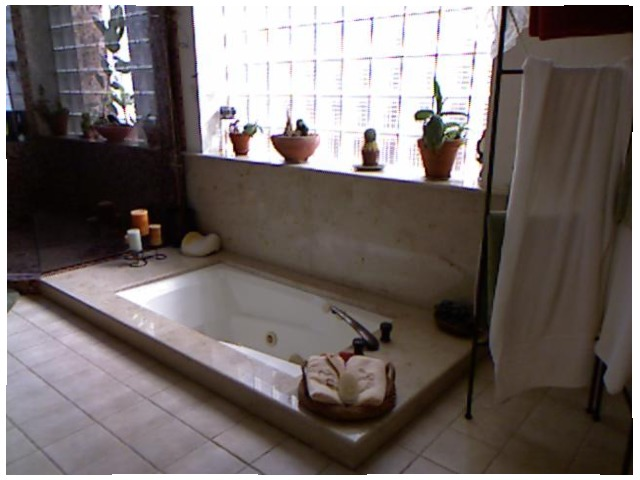<image>
Is there a candle on the cactus? No. The candle is not positioned on the cactus. They may be near each other, but the candle is not supported by or resting on top of the cactus. Is the window behind the plant? Yes. From this viewpoint, the window is positioned behind the plant, with the plant partially or fully occluding the window. Is the plant above the bath? Yes. The plant is positioned above the bath in the vertical space, higher up in the scene. Where is the plant in relation to the cloth? Is it to the right of the cloth? Yes. From this viewpoint, the plant is positioned to the right side relative to the cloth. 